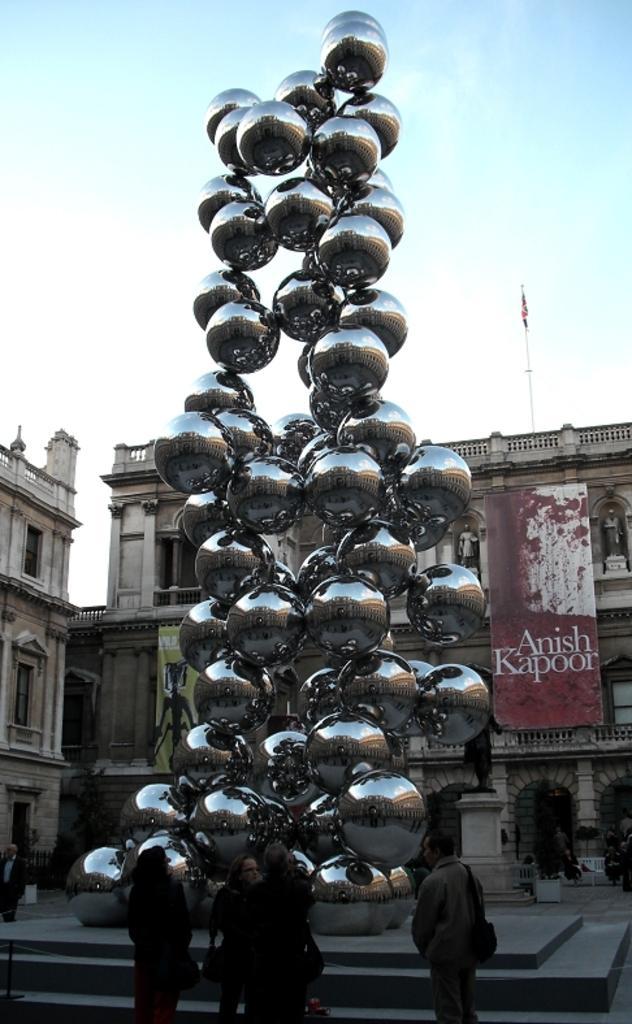Could you give a brief overview of what you see in this image? In this picture I can see people standing. I can see spherical sculpture. I can see buildings in the background. I can see banner. I can see clear sky. 